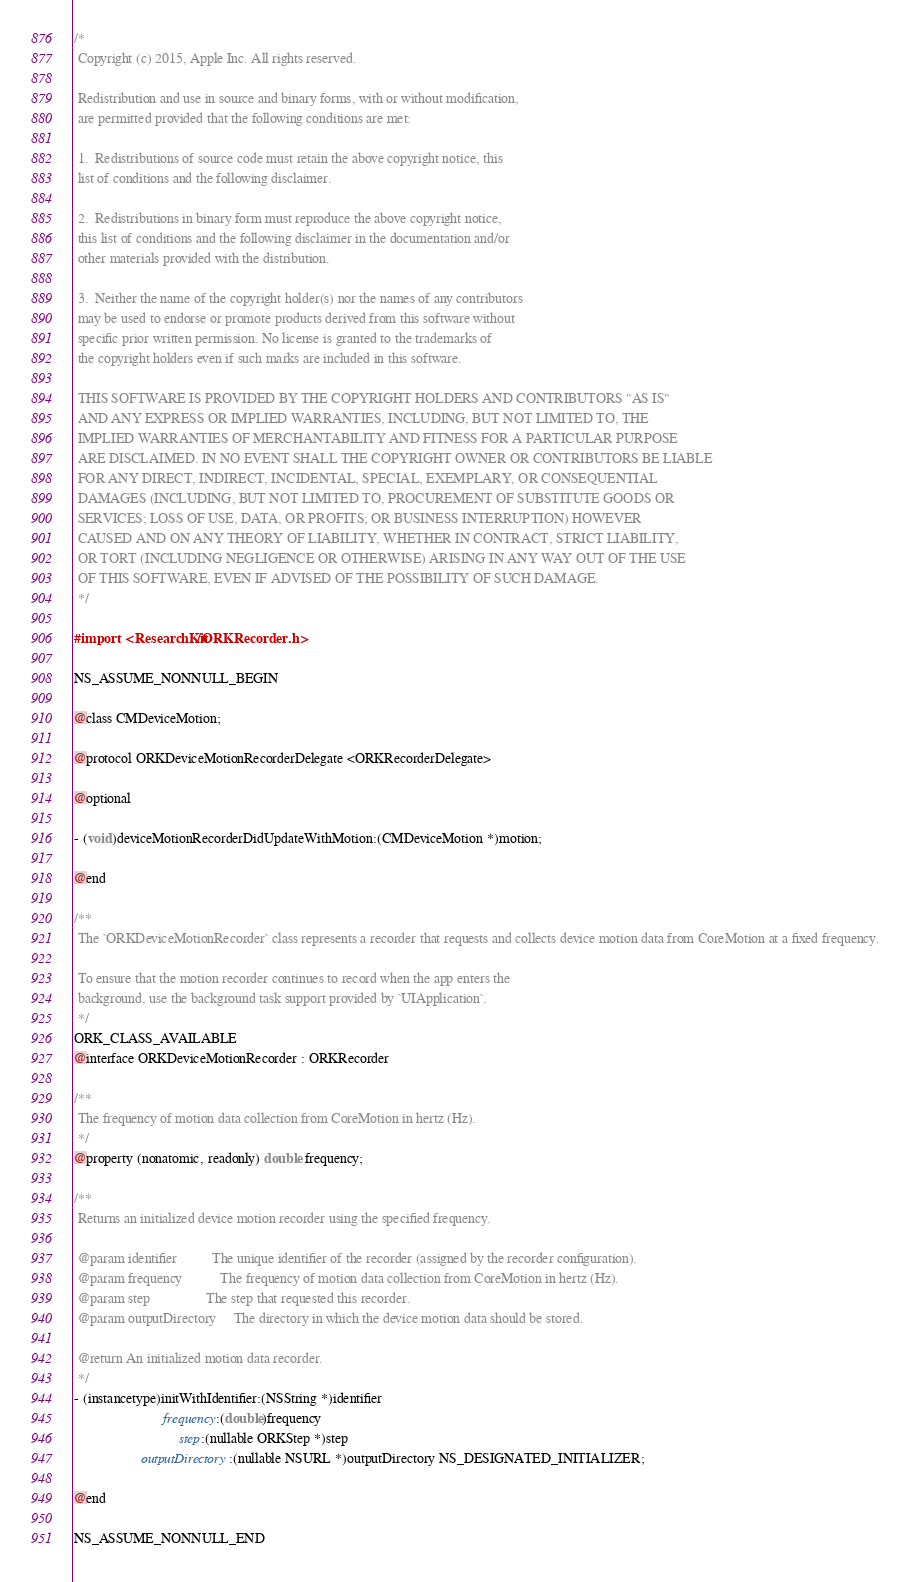<code> <loc_0><loc_0><loc_500><loc_500><_C_>/*
 Copyright (c) 2015, Apple Inc. All rights reserved.
 
 Redistribution and use in source and binary forms, with or without modification,
 are permitted provided that the following conditions are met:
 
 1.  Redistributions of source code must retain the above copyright notice, this
 list of conditions and the following disclaimer.
 
 2.  Redistributions in binary form must reproduce the above copyright notice,
 this list of conditions and the following disclaimer in the documentation and/or
 other materials provided with the distribution.
 
 3.  Neither the name of the copyright holder(s) nor the names of any contributors
 may be used to endorse or promote products derived from this software without
 specific prior written permission. No license is granted to the trademarks of
 the copyright holders even if such marks are included in this software.
 
 THIS SOFTWARE IS PROVIDED BY THE COPYRIGHT HOLDERS AND CONTRIBUTORS "AS IS"
 AND ANY EXPRESS OR IMPLIED WARRANTIES, INCLUDING, BUT NOT LIMITED TO, THE
 IMPLIED WARRANTIES OF MERCHANTABILITY AND FITNESS FOR A PARTICULAR PURPOSE
 ARE DISCLAIMED. IN NO EVENT SHALL THE COPYRIGHT OWNER OR CONTRIBUTORS BE LIABLE
 FOR ANY DIRECT, INDIRECT, INCIDENTAL, SPECIAL, EXEMPLARY, OR CONSEQUENTIAL
 DAMAGES (INCLUDING, BUT NOT LIMITED TO, PROCUREMENT OF SUBSTITUTE GOODS OR
 SERVICES; LOSS OF USE, DATA, OR PROFITS; OR BUSINESS INTERRUPTION) HOWEVER
 CAUSED AND ON ANY THEORY OF LIABILITY, WHETHER IN CONTRACT, STRICT LIABILITY,
 OR TORT (INCLUDING NEGLIGENCE OR OTHERWISE) ARISING IN ANY WAY OUT OF THE USE
 OF THIS SOFTWARE, EVEN IF ADVISED OF THE POSSIBILITY OF SUCH DAMAGE.
 */

#import <ResearchKit/ORKRecorder.h>

NS_ASSUME_NONNULL_BEGIN

@class CMDeviceMotion;

@protocol ORKDeviceMotionRecorderDelegate <ORKRecorderDelegate>

@optional

- (void)deviceMotionRecorderDidUpdateWithMotion:(CMDeviceMotion *)motion;

@end

/**
 The `ORKDeviceMotionRecorder` class represents a recorder that requests and collects device motion data from CoreMotion at a fixed frequency.
 
 To ensure that the motion recorder continues to record when the app enters the
 background, use the background task support provided by `UIApplication`.
 */
ORK_CLASS_AVAILABLE
@interface ORKDeviceMotionRecorder : ORKRecorder

/**
 The frequency of motion data collection from CoreMotion in hertz (Hz).
 */
@property (nonatomic, readonly) double frequency;

/**
 Returns an initialized device motion recorder using the specified frequency.
 
 @param identifier          The unique identifier of the recorder (assigned by the recorder configuration).
 @param frequency           The frequency of motion data collection from CoreMotion in hertz (Hz).
 @param step                The step that requested this recorder.
 @param outputDirectory     The directory in which the device motion data should be stored.
 
 @return An initialized motion data recorder.
 */
- (instancetype)initWithIdentifier:(NSString *)identifier
                         frequency:(double)frequency
                              step:(nullable ORKStep *)step
                   outputDirectory:(nullable NSURL *)outputDirectory NS_DESIGNATED_INITIALIZER;

@end

NS_ASSUME_NONNULL_END
</code> 